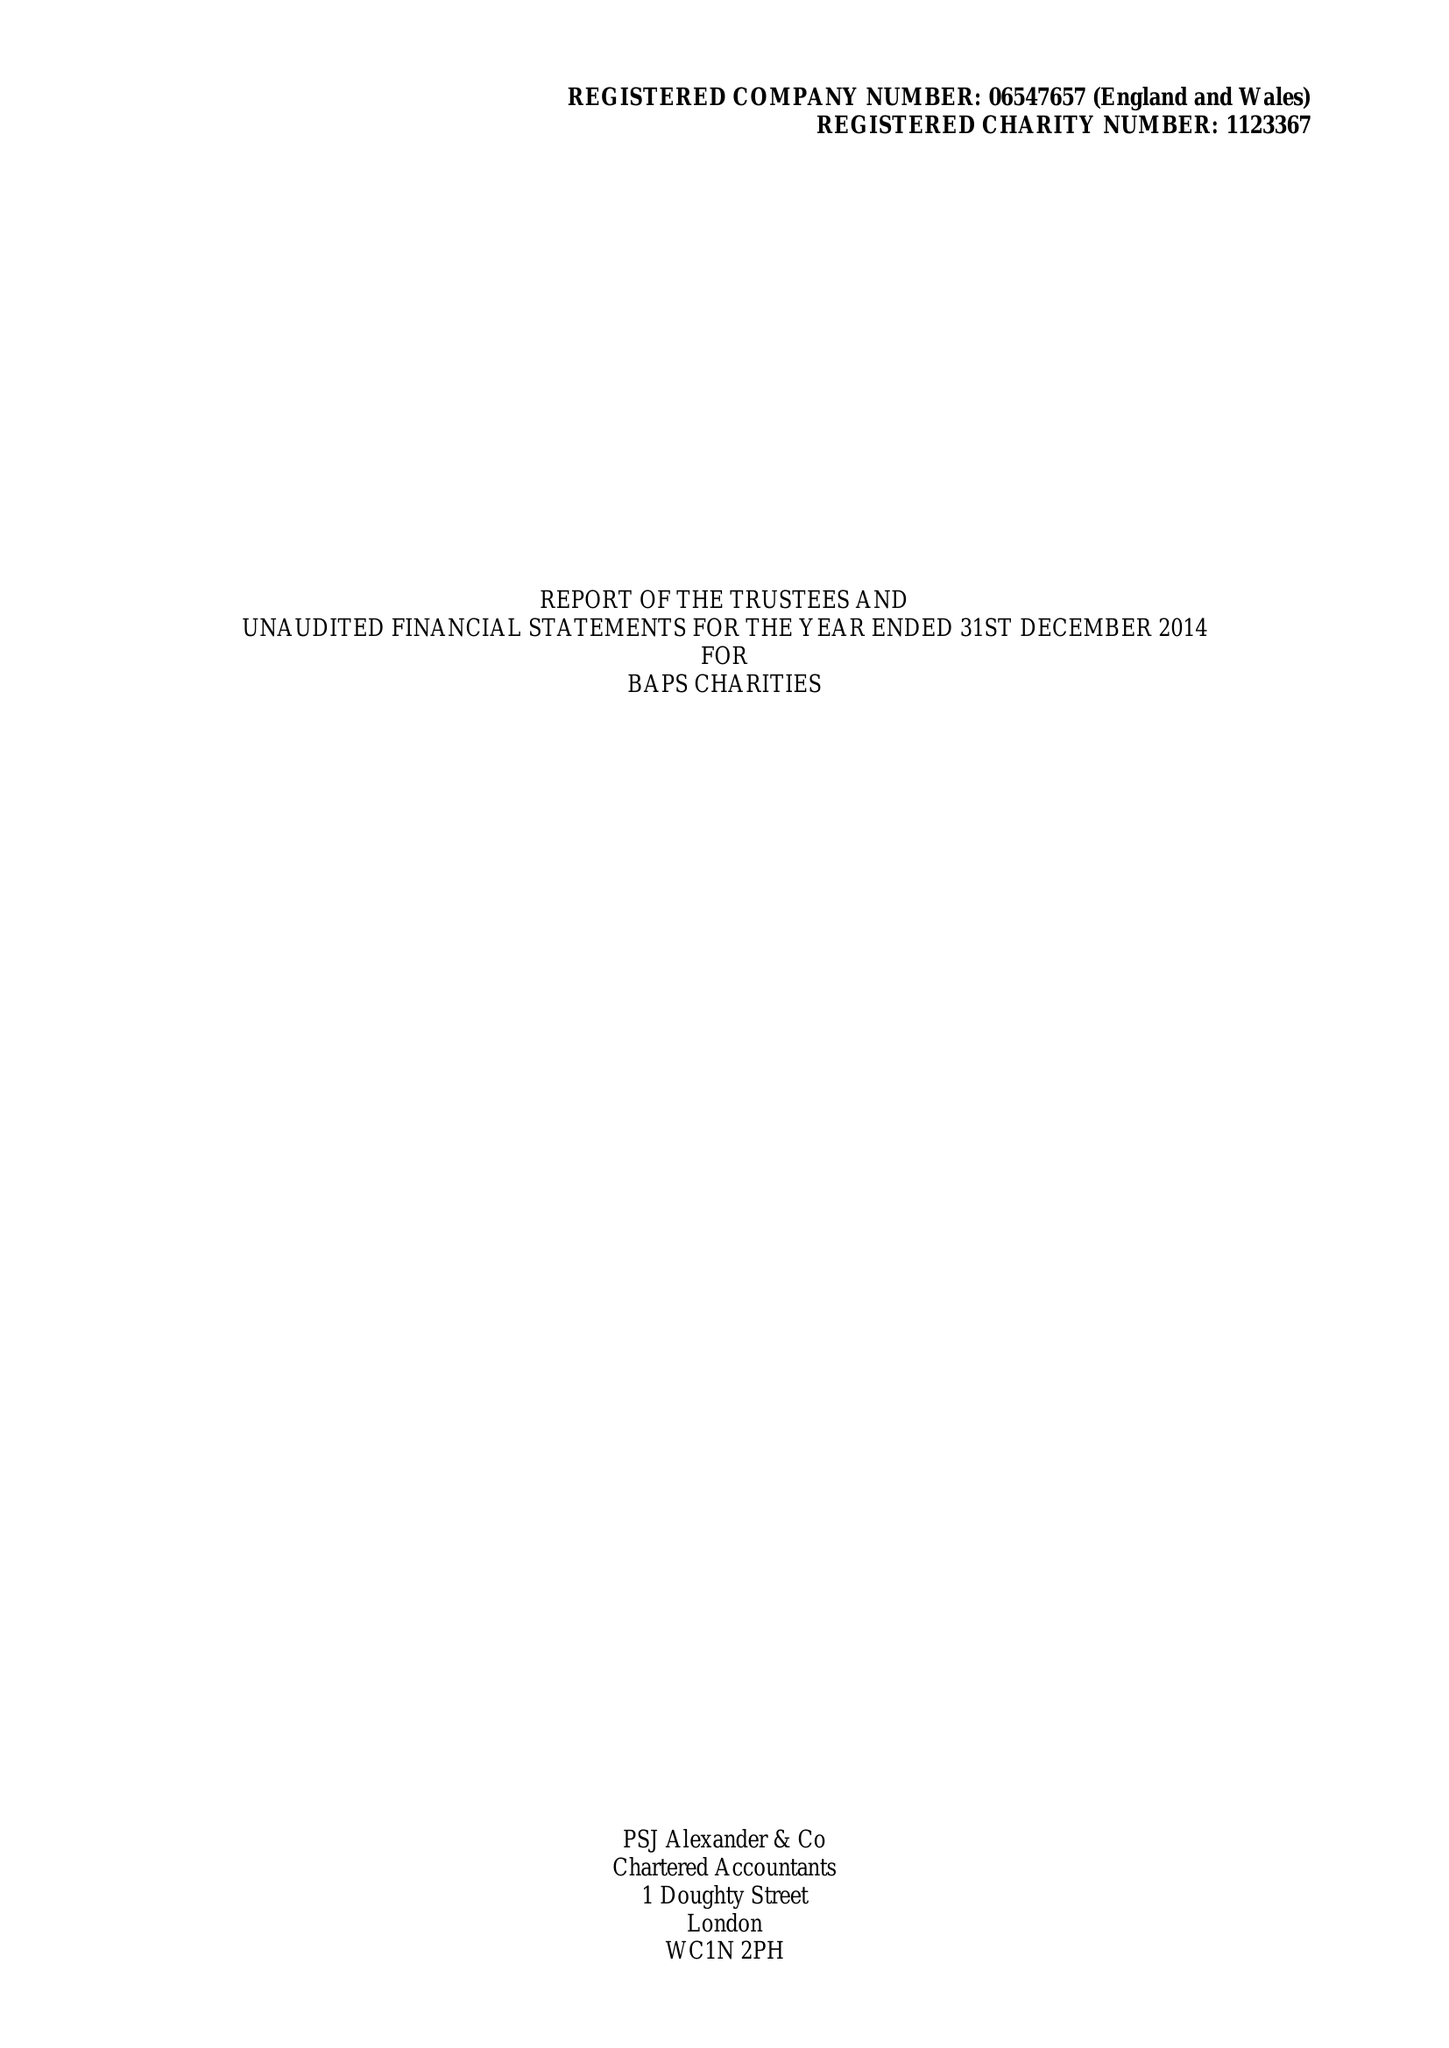What is the value for the address__postcode?
Answer the question using a single word or phrase. NW10 8HD 